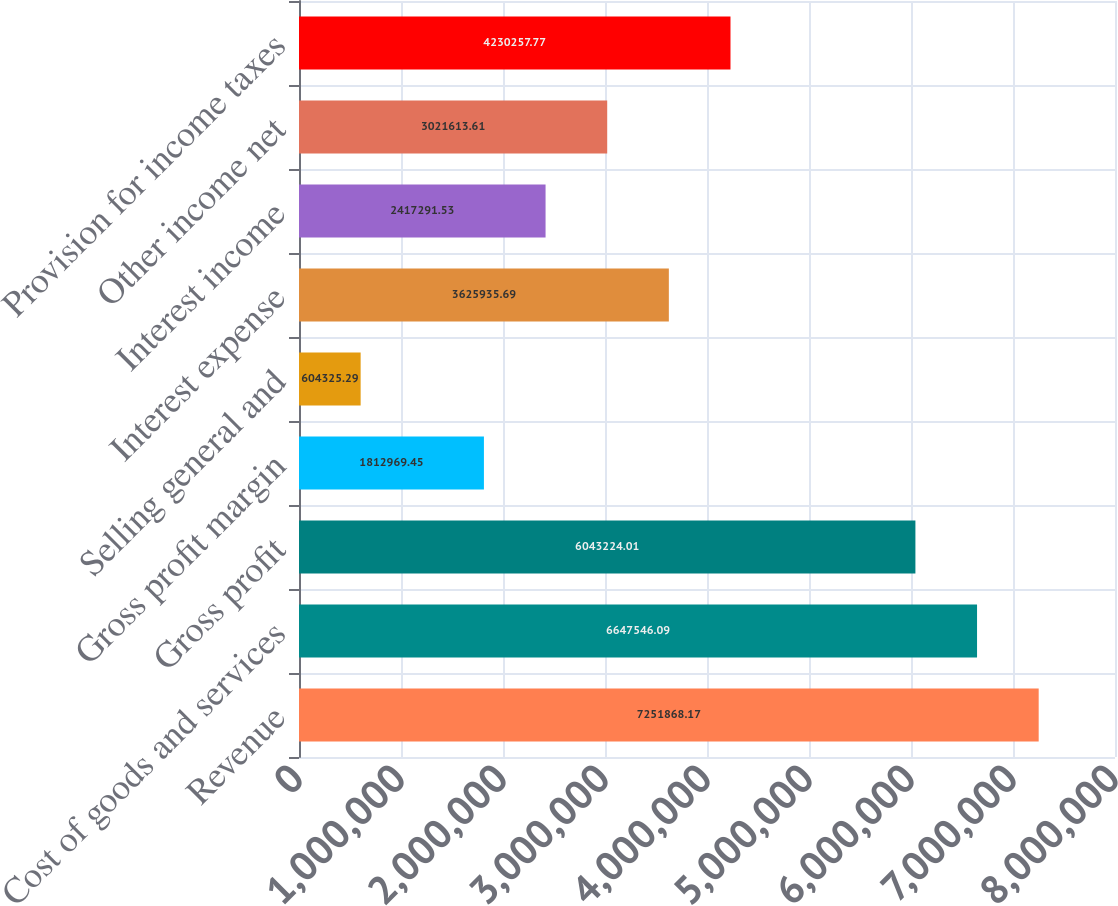Convert chart. <chart><loc_0><loc_0><loc_500><loc_500><bar_chart><fcel>Revenue<fcel>Cost of goods and services<fcel>Gross profit<fcel>Gross profit margin<fcel>Selling general and<fcel>Interest expense<fcel>Interest income<fcel>Other income net<fcel>Provision for income taxes<nl><fcel>7.25187e+06<fcel>6.64755e+06<fcel>6.04322e+06<fcel>1.81297e+06<fcel>604325<fcel>3.62594e+06<fcel>2.41729e+06<fcel>3.02161e+06<fcel>4.23026e+06<nl></chart> 